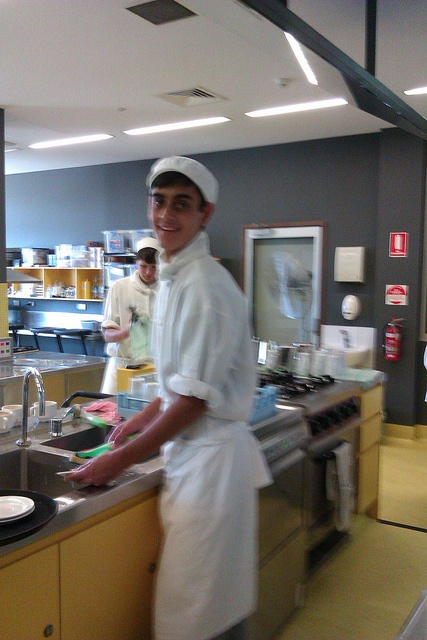Describe the objects in this image and their specific colors. I can see people in lightgray, darkgray, gray, and maroon tones, oven in lightgray, black, and gray tones, people in lightgray and darkgray tones, sink in lightgray, black, gray, and darkgray tones, and sink in lightgray, darkgray, and gray tones in this image. 